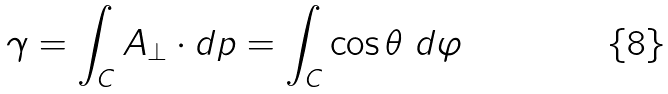<formula> <loc_0><loc_0><loc_500><loc_500>\gamma = \int _ { C } { A } _ { \bot } \cdot d { p } = \int _ { C } \cos \theta \ d \varphi</formula> 